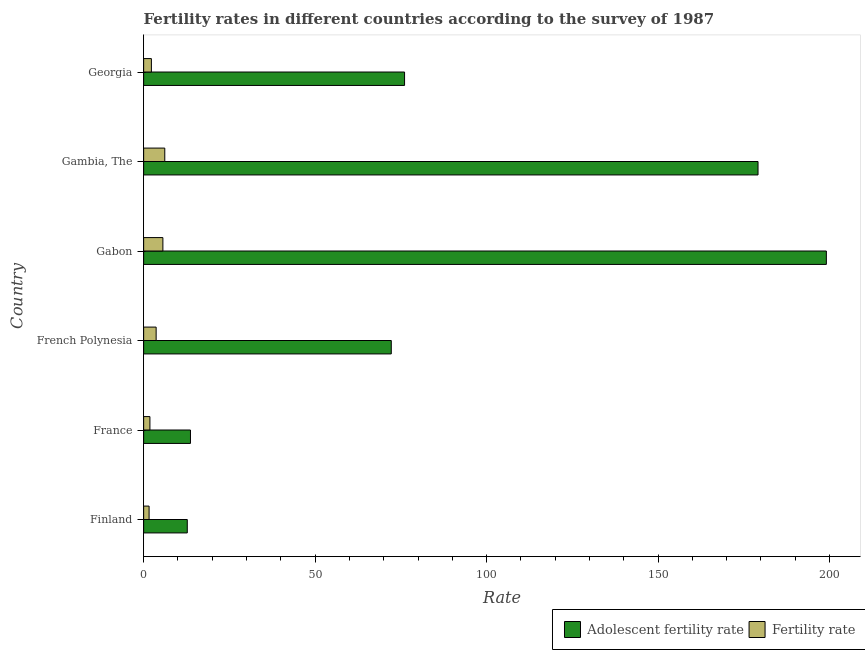How many groups of bars are there?
Provide a succinct answer. 6. Are the number of bars on each tick of the Y-axis equal?
Your answer should be compact. Yes. How many bars are there on the 3rd tick from the top?
Keep it short and to the point. 2. How many bars are there on the 6th tick from the bottom?
Keep it short and to the point. 2. What is the label of the 1st group of bars from the top?
Your answer should be compact. Georgia. In how many cases, is the number of bars for a given country not equal to the number of legend labels?
Make the answer very short. 0. What is the fertility rate in Finland?
Offer a very short reply. 1.59. Across all countries, what is the maximum adolescent fertility rate?
Provide a succinct answer. 199.07. Across all countries, what is the minimum adolescent fertility rate?
Provide a succinct answer. 12.72. In which country was the fertility rate maximum?
Offer a terse response. Gambia, The. What is the total adolescent fertility rate in the graph?
Give a very brief answer. 552.89. What is the difference between the fertility rate in France and that in Georgia?
Offer a very short reply. -0.43. What is the difference between the adolescent fertility rate in Finland and the fertility rate in Georgia?
Your answer should be very brief. 10.46. What is the average fertility rate per country?
Ensure brevity in your answer.  3.52. What is the difference between the fertility rate and adolescent fertility rate in French Polynesia?
Your response must be concise. -68.56. In how many countries, is the fertility rate greater than 110 ?
Your answer should be compact. 0. What is the ratio of the fertility rate in France to that in Gabon?
Your answer should be compact. 0.33. Is the difference between the adolescent fertility rate in Finland and France greater than the difference between the fertility rate in Finland and France?
Offer a terse response. No. What is the difference between the highest and the second highest fertility rate?
Provide a succinct answer. 0.56. What is the difference between the highest and the lowest adolescent fertility rate?
Offer a terse response. 186.35. In how many countries, is the fertility rate greater than the average fertility rate taken over all countries?
Make the answer very short. 3. What does the 2nd bar from the top in Gabon represents?
Provide a short and direct response. Adolescent fertility rate. What does the 2nd bar from the bottom in Gambia, The represents?
Keep it short and to the point. Fertility rate. How many countries are there in the graph?
Make the answer very short. 6. Does the graph contain grids?
Your answer should be compact. No. How many legend labels are there?
Keep it short and to the point. 2. What is the title of the graph?
Provide a succinct answer. Fertility rates in different countries according to the survey of 1987. Does "Domestic liabilities" appear as one of the legend labels in the graph?
Offer a terse response. No. What is the label or title of the X-axis?
Your response must be concise. Rate. What is the Rate of Adolescent fertility rate in Finland?
Give a very brief answer. 12.72. What is the Rate of Fertility rate in Finland?
Make the answer very short. 1.59. What is the Rate in Adolescent fertility rate in France?
Make the answer very short. 13.65. What is the Rate of Fertility rate in France?
Offer a terse response. 1.83. What is the Rate in Adolescent fertility rate in French Polynesia?
Offer a terse response. 72.21. What is the Rate in Fertility rate in French Polynesia?
Your answer should be compact. 3.65. What is the Rate of Adolescent fertility rate in Gabon?
Your response must be concise. 199.07. What is the Rate of Fertility rate in Gabon?
Provide a succinct answer. 5.61. What is the Rate of Adolescent fertility rate in Gambia, The?
Make the answer very short. 179.15. What is the Rate of Fertility rate in Gambia, The?
Your response must be concise. 6.16. What is the Rate of Adolescent fertility rate in Georgia?
Ensure brevity in your answer.  76.08. What is the Rate of Fertility rate in Georgia?
Your answer should be very brief. 2.26. Across all countries, what is the maximum Rate in Adolescent fertility rate?
Your answer should be compact. 199.07. Across all countries, what is the maximum Rate in Fertility rate?
Make the answer very short. 6.16. Across all countries, what is the minimum Rate in Adolescent fertility rate?
Offer a very short reply. 12.72. Across all countries, what is the minimum Rate in Fertility rate?
Your answer should be very brief. 1.59. What is the total Rate in Adolescent fertility rate in the graph?
Your answer should be compact. 552.89. What is the total Rate of Fertility rate in the graph?
Make the answer very short. 21.1. What is the difference between the Rate in Adolescent fertility rate in Finland and that in France?
Make the answer very short. -0.93. What is the difference between the Rate of Fertility rate in Finland and that in France?
Keep it short and to the point. -0.24. What is the difference between the Rate in Adolescent fertility rate in Finland and that in French Polynesia?
Provide a succinct answer. -59.48. What is the difference between the Rate of Fertility rate in Finland and that in French Polynesia?
Ensure brevity in your answer.  -2.06. What is the difference between the Rate in Adolescent fertility rate in Finland and that in Gabon?
Provide a succinct answer. -186.35. What is the difference between the Rate in Fertility rate in Finland and that in Gabon?
Make the answer very short. -4.02. What is the difference between the Rate of Adolescent fertility rate in Finland and that in Gambia, The?
Your response must be concise. -166.43. What is the difference between the Rate in Fertility rate in Finland and that in Gambia, The?
Give a very brief answer. -4.57. What is the difference between the Rate of Adolescent fertility rate in Finland and that in Georgia?
Offer a terse response. -63.36. What is the difference between the Rate in Fertility rate in Finland and that in Georgia?
Offer a very short reply. -0.67. What is the difference between the Rate in Adolescent fertility rate in France and that in French Polynesia?
Offer a very short reply. -58.55. What is the difference between the Rate in Fertility rate in France and that in French Polynesia?
Ensure brevity in your answer.  -1.81. What is the difference between the Rate in Adolescent fertility rate in France and that in Gabon?
Your response must be concise. -185.42. What is the difference between the Rate in Fertility rate in France and that in Gabon?
Make the answer very short. -3.78. What is the difference between the Rate of Adolescent fertility rate in France and that in Gambia, The?
Offer a very short reply. -165.5. What is the difference between the Rate of Fertility rate in France and that in Gambia, The?
Give a very brief answer. -4.33. What is the difference between the Rate in Adolescent fertility rate in France and that in Georgia?
Offer a very short reply. -62.43. What is the difference between the Rate in Fertility rate in France and that in Georgia?
Your answer should be compact. -0.43. What is the difference between the Rate in Adolescent fertility rate in French Polynesia and that in Gabon?
Ensure brevity in your answer.  -126.87. What is the difference between the Rate of Fertility rate in French Polynesia and that in Gabon?
Offer a very short reply. -1.96. What is the difference between the Rate of Adolescent fertility rate in French Polynesia and that in Gambia, The?
Ensure brevity in your answer.  -106.94. What is the difference between the Rate of Fertility rate in French Polynesia and that in Gambia, The?
Offer a very short reply. -2.52. What is the difference between the Rate in Adolescent fertility rate in French Polynesia and that in Georgia?
Offer a very short reply. -3.87. What is the difference between the Rate in Fertility rate in French Polynesia and that in Georgia?
Give a very brief answer. 1.39. What is the difference between the Rate in Adolescent fertility rate in Gabon and that in Gambia, The?
Offer a terse response. 19.92. What is the difference between the Rate in Fertility rate in Gabon and that in Gambia, The?
Your answer should be very brief. -0.56. What is the difference between the Rate of Adolescent fertility rate in Gabon and that in Georgia?
Your response must be concise. 122.99. What is the difference between the Rate of Fertility rate in Gabon and that in Georgia?
Provide a succinct answer. 3.35. What is the difference between the Rate of Adolescent fertility rate in Gambia, The and that in Georgia?
Your response must be concise. 103.07. What is the difference between the Rate of Fertility rate in Gambia, The and that in Georgia?
Offer a very short reply. 3.9. What is the difference between the Rate of Adolescent fertility rate in Finland and the Rate of Fertility rate in France?
Make the answer very short. 10.89. What is the difference between the Rate in Adolescent fertility rate in Finland and the Rate in Fertility rate in French Polynesia?
Give a very brief answer. 9.08. What is the difference between the Rate in Adolescent fertility rate in Finland and the Rate in Fertility rate in Gabon?
Offer a terse response. 7.12. What is the difference between the Rate of Adolescent fertility rate in Finland and the Rate of Fertility rate in Gambia, The?
Ensure brevity in your answer.  6.56. What is the difference between the Rate of Adolescent fertility rate in Finland and the Rate of Fertility rate in Georgia?
Make the answer very short. 10.46. What is the difference between the Rate in Adolescent fertility rate in France and the Rate in Fertility rate in French Polynesia?
Give a very brief answer. 10.01. What is the difference between the Rate of Adolescent fertility rate in France and the Rate of Fertility rate in Gabon?
Make the answer very short. 8.04. What is the difference between the Rate of Adolescent fertility rate in France and the Rate of Fertility rate in Gambia, The?
Your answer should be compact. 7.49. What is the difference between the Rate of Adolescent fertility rate in France and the Rate of Fertility rate in Georgia?
Keep it short and to the point. 11.39. What is the difference between the Rate in Adolescent fertility rate in French Polynesia and the Rate in Fertility rate in Gabon?
Your answer should be compact. 66.6. What is the difference between the Rate in Adolescent fertility rate in French Polynesia and the Rate in Fertility rate in Gambia, The?
Give a very brief answer. 66.04. What is the difference between the Rate in Adolescent fertility rate in French Polynesia and the Rate in Fertility rate in Georgia?
Your response must be concise. 69.95. What is the difference between the Rate of Adolescent fertility rate in Gabon and the Rate of Fertility rate in Gambia, The?
Give a very brief answer. 192.91. What is the difference between the Rate of Adolescent fertility rate in Gabon and the Rate of Fertility rate in Georgia?
Your answer should be compact. 196.81. What is the difference between the Rate of Adolescent fertility rate in Gambia, The and the Rate of Fertility rate in Georgia?
Offer a very short reply. 176.89. What is the average Rate in Adolescent fertility rate per country?
Offer a terse response. 92.15. What is the average Rate of Fertility rate per country?
Keep it short and to the point. 3.52. What is the difference between the Rate in Adolescent fertility rate and Rate in Fertility rate in Finland?
Provide a succinct answer. 11.13. What is the difference between the Rate in Adolescent fertility rate and Rate in Fertility rate in France?
Make the answer very short. 11.82. What is the difference between the Rate in Adolescent fertility rate and Rate in Fertility rate in French Polynesia?
Provide a succinct answer. 68.56. What is the difference between the Rate of Adolescent fertility rate and Rate of Fertility rate in Gabon?
Provide a short and direct response. 193.47. What is the difference between the Rate in Adolescent fertility rate and Rate in Fertility rate in Gambia, The?
Keep it short and to the point. 172.99. What is the difference between the Rate in Adolescent fertility rate and Rate in Fertility rate in Georgia?
Offer a terse response. 73.82. What is the ratio of the Rate of Adolescent fertility rate in Finland to that in France?
Keep it short and to the point. 0.93. What is the ratio of the Rate of Fertility rate in Finland to that in France?
Provide a succinct answer. 0.87. What is the ratio of the Rate in Adolescent fertility rate in Finland to that in French Polynesia?
Ensure brevity in your answer.  0.18. What is the ratio of the Rate in Fertility rate in Finland to that in French Polynesia?
Provide a short and direct response. 0.44. What is the ratio of the Rate of Adolescent fertility rate in Finland to that in Gabon?
Offer a very short reply. 0.06. What is the ratio of the Rate in Fertility rate in Finland to that in Gabon?
Provide a succinct answer. 0.28. What is the ratio of the Rate of Adolescent fertility rate in Finland to that in Gambia, The?
Your response must be concise. 0.07. What is the ratio of the Rate in Fertility rate in Finland to that in Gambia, The?
Provide a succinct answer. 0.26. What is the ratio of the Rate in Adolescent fertility rate in Finland to that in Georgia?
Offer a terse response. 0.17. What is the ratio of the Rate in Fertility rate in Finland to that in Georgia?
Your response must be concise. 0.7. What is the ratio of the Rate of Adolescent fertility rate in France to that in French Polynesia?
Keep it short and to the point. 0.19. What is the ratio of the Rate of Fertility rate in France to that in French Polynesia?
Offer a terse response. 0.5. What is the ratio of the Rate of Adolescent fertility rate in France to that in Gabon?
Ensure brevity in your answer.  0.07. What is the ratio of the Rate in Fertility rate in France to that in Gabon?
Provide a short and direct response. 0.33. What is the ratio of the Rate in Adolescent fertility rate in France to that in Gambia, The?
Offer a very short reply. 0.08. What is the ratio of the Rate of Fertility rate in France to that in Gambia, The?
Offer a terse response. 0.3. What is the ratio of the Rate of Adolescent fertility rate in France to that in Georgia?
Provide a succinct answer. 0.18. What is the ratio of the Rate in Fertility rate in France to that in Georgia?
Your response must be concise. 0.81. What is the ratio of the Rate in Adolescent fertility rate in French Polynesia to that in Gabon?
Keep it short and to the point. 0.36. What is the ratio of the Rate in Fertility rate in French Polynesia to that in Gabon?
Your answer should be very brief. 0.65. What is the ratio of the Rate in Adolescent fertility rate in French Polynesia to that in Gambia, The?
Offer a terse response. 0.4. What is the ratio of the Rate in Fertility rate in French Polynesia to that in Gambia, The?
Give a very brief answer. 0.59. What is the ratio of the Rate in Adolescent fertility rate in French Polynesia to that in Georgia?
Give a very brief answer. 0.95. What is the ratio of the Rate in Fertility rate in French Polynesia to that in Georgia?
Offer a very short reply. 1.61. What is the ratio of the Rate of Adolescent fertility rate in Gabon to that in Gambia, The?
Make the answer very short. 1.11. What is the ratio of the Rate of Fertility rate in Gabon to that in Gambia, The?
Give a very brief answer. 0.91. What is the ratio of the Rate in Adolescent fertility rate in Gabon to that in Georgia?
Offer a terse response. 2.62. What is the ratio of the Rate of Fertility rate in Gabon to that in Georgia?
Offer a very short reply. 2.48. What is the ratio of the Rate of Adolescent fertility rate in Gambia, The to that in Georgia?
Make the answer very short. 2.35. What is the ratio of the Rate of Fertility rate in Gambia, The to that in Georgia?
Provide a short and direct response. 2.73. What is the difference between the highest and the second highest Rate in Adolescent fertility rate?
Provide a succinct answer. 19.92. What is the difference between the highest and the second highest Rate in Fertility rate?
Provide a short and direct response. 0.56. What is the difference between the highest and the lowest Rate of Adolescent fertility rate?
Provide a short and direct response. 186.35. What is the difference between the highest and the lowest Rate of Fertility rate?
Offer a very short reply. 4.57. 